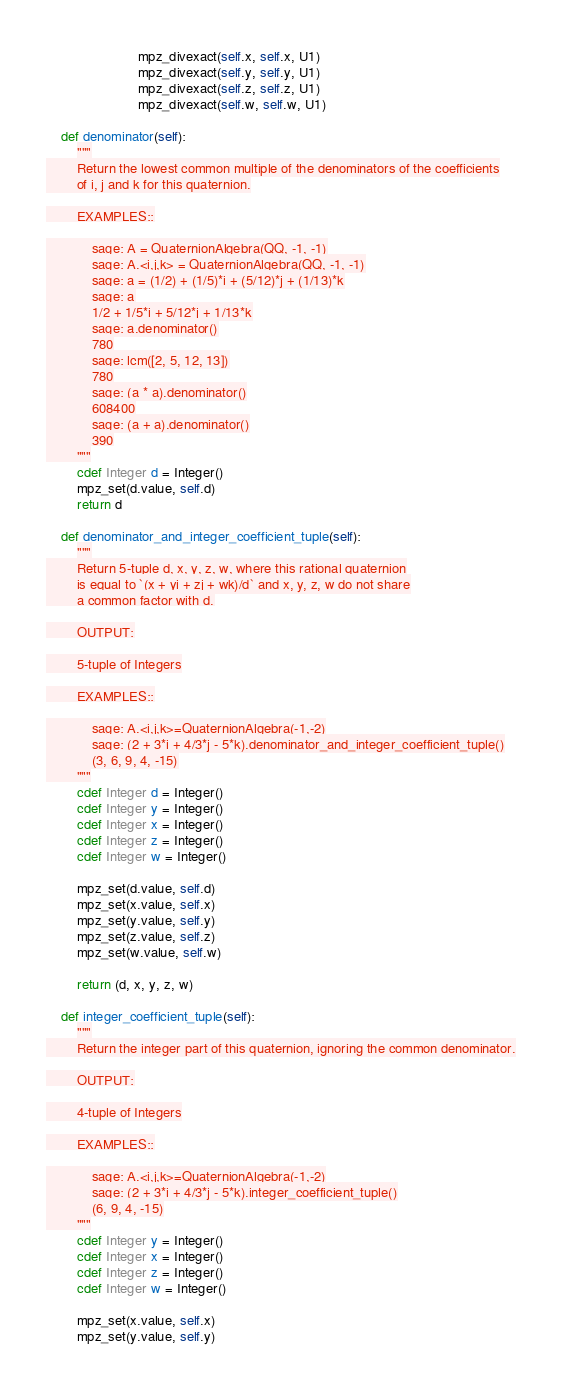Convert code to text. <code><loc_0><loc_0><loc_500><loc_500><_Cython_>                        mpz_divexact(self.x, self.x, U1)
                        mpz_divexact(self.y, self.y, U1)
                        mpz_divexact(self.z, self.z, U1)
                        mpz_divexact(self.w, self.w, U1)

    def denominator(self):
        """
        Return the lowest common multiple of the denominators of the coefficients
        of i, j and k for this quaternion.

        EXAMPLES::

            sage: A = QuaternionAlgebra(QQ, -1, -1)
            sage: A.<i,j,k> = QuaternionAlgebra(QQ, -1, -1)
            sage: a = (1/2) + (1/5)*i + (5/12)*j + (1/13)*k
            sage: a
            1/2 + 1/5*i + 5/12*j + 1/13*k
            sage: a.denominator()
            780
            sage: lcm([2, 5, 12, 13])
            780
            sage: (a * a).denominator()
            608400
            sage: (a + a).denominator()
            390
        """
        cdef Integer d = Integer()
        mpz_set(d.value, self.d)
        return d

    def denominator_and_integer_coefficient_tuple(self):
        """
        Return 5-tuple d, x, y, z, w, where this rational quaternion
        is equal to `(x + yi + zj + wk)/d` and x, y, z, w do not share
        a common factor with d.

        OUTPUT:

        5-tuple of Integers

        EXAMPLES::

            sage: A.<i,j,k>=QuaternionAlgebra(-1,-2)
            sage: (2 + 3*i + 4/3*j - 5*k).denominator_and_integer_coefficient_tuple()
            (3, 6, 9, 4, -15)
        """
        cdef Integer d = Integer()
        cdef Integer y = Integer()
        cdef Integer x = Integer()
        cdef Integer z = Integer()
        cdef Integer w = Integer()

        mpz_set(d.value, self.d)
        mpz_set(x.value, self.x)
        mpz_set(y.value, self.y)
        mpz_set(z.value, self.z)
        mpz_set(w.value, self.w)

        return (d, x, y, z, w)

    def integer_coefficient_tuple(self):
        """
        Return the integer part of this quaternion, ignoring the common denominator.

        OUTPUT:

        4-tuple of Integers

        EXAMPLES::

            sage: A.<i,j,k>=QuaternionAlgebra(-1,-2)
            sage: (2 + 3*i + 4/3*j - 5*k).integer_coefficient_tuple()
            (6, 9, 4, -15)
        """
        cdef Integer y = Integer()
        cdef Integer x = Integer()
        cdef Integer z = Integer()
        cdef Integer w = Integer()

        mpz_set(x.value, self.x)
        mpz_set(y.value, self.y)</code> 